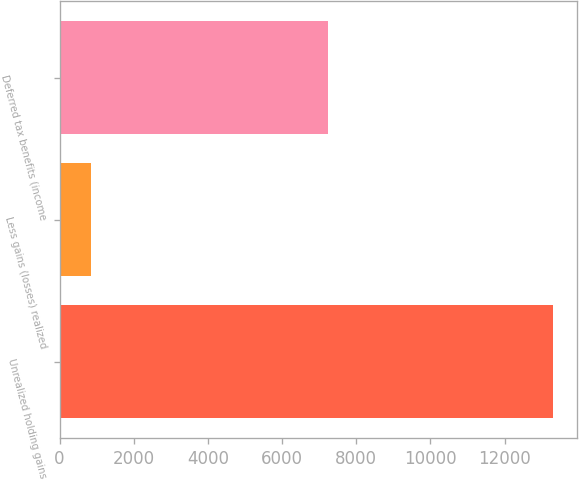<chart> <loc_0><loc_0><loc_500><loc_500><bar_chart><fcel>Unrealized holding gains<fcel>Less gains (losses) realized<fcel>Deferred tax benefits (income<nl><fcel>13298<fcel>839<fcel>7230<nl></chart> 